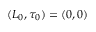<formula> <loc_0><loc_0><loc_500><loc_500>( L _ { 0 } , \tau _ { 0 } ) = ( 0 , 0 )</formula> 